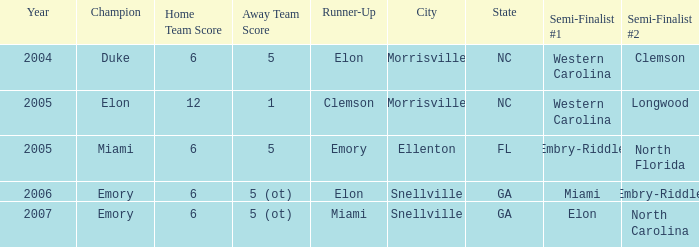How many teams were listed as runner up in 2005 and there the first semi finalist was Western Carolina? 1.0. 